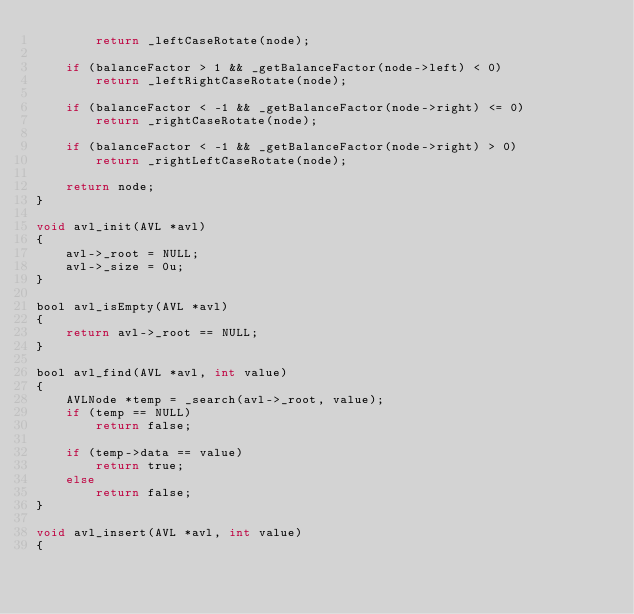Convert code to text. <code><loc_0><loc_0><loc_500><loc_500><_C_>        return _leftCaseRotate(node);

    if (balanceFactor > 1 && _getBalanceFactor(node->left) < 0)
        return _leftRightCaseRotate(node);

    if (balanceFactor < -1 && _getBalanceFactor(node->right) <= 0)
        return _rightCaseRotate(node);

    if (balanceFactor < -1 && _getBalanceFactor(node->right) > 0)
        return _rightLeftCaseRotate(node);

    return node;
}

void avl_init(AVL *avl)
{
    avl->_root = NULL;
    avl->_size = 0u;
}

bool avl_isEmpty(AVL *avl)
{
    return avl->_root == NULL;
}

bool avl_find(AVL *avl, int value)
{
    AVLNode *temp = _search(avl->_root, value);
    if (temp == NULL)
        return false;

    if (temp->data == value)
        return true;
    else
        return false;
}

void avl_insert(AVL *avl, int value)
{</code> 